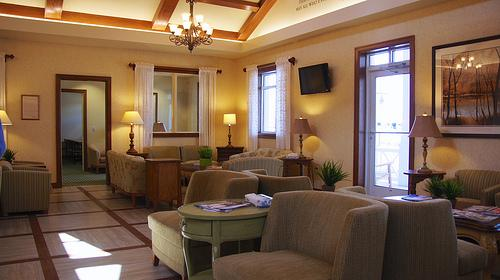Mention some of the items present on the round table. The round table has magazines and tissues. Identify the type of door and the material it is made from. The door is a glass door entrance made of glass material. Discuss some of the lighting elements in the room. There are five lamps, decorative lights hanging from the ceiling, a chandelier, and sunlight on the floor. Provide a summary of the objects and the environment in the image. A tidy, spacious waiting room with a glass door entrance, tan circular padded chairs, tan checker pattern floor, green plants, lamps, round table with magazines, flat screen TV, chandelier, and large windows looking outside. What type of room is depicted in the image and what is its purpose? The image shows a waiting room for people to relax and spend time before their appointments or meetings. Describe the pattern present on the floor. The floor has a tan checker pattern. What type of seating arrangement is available in the room? There are tan circular padded chairs arranged around small tables. Analyze the room's overall atmosphere based on the given information. The room has a calm, peaceful, and welcoming atmosphere, with comfortable seating, natural light, plants, and a clean, organized look. List some of the plants observed in this room. There is a green plant on the table and another green plant on the floor. Is the blue painting on the wall a landscape or a portrait? No, it's not mentioned in the image. What is the sentiment of the image? The image has a calm and inviting sentiment. Enumerate all the light sources in the room. There are five lamps, a chandelier, a ceiling light, and sunlight coming from the windows. Identify any anomalies in the image. No anomalies detected in the image. How many windows can you see in the image? There are two windows looking outside. Is the chandelier on or off? The chandelier is on, and the ceiling light is also on. What is the dominant color of the chairs in the room? The chairs are tan in color. How many lamps are there in the corner of the room? There is one lamp in the corner of the room. Identify the source of sunlight in the image. The sunlight is coming through the two windows looking outside. Describe the plant in the room. There is a green plant on the table and a green plant on the floor. What is the color of the curtains in the room? The curtains are white. Are there any people in the room? There are no people in the large room. Which objects in the room are used for decoration? The decorative items include a painting, green plants, lamps, and decorative lights hanging from the ceiling. What does the painting in the room depict? The painting shows light reflecting. Is the photo taken during the day or night? The photo is taken during the day. What type of door is present in the room? There is a glass door entrance. Describe the waiting room in the image. The waiting room is neat and clean with light-colored walls, tan circular padded chairs, a round table with magazines and tissues, a flat screen television, a chandelier, and a glass door entrance. Is the flat screen television turned on or off? The flat screen television is not turned on. Detect and describe the interaction between the chairs and the table. Small tables are placed between the chairs, separating them. What objects are on the green table? There are magazines on the green table. 